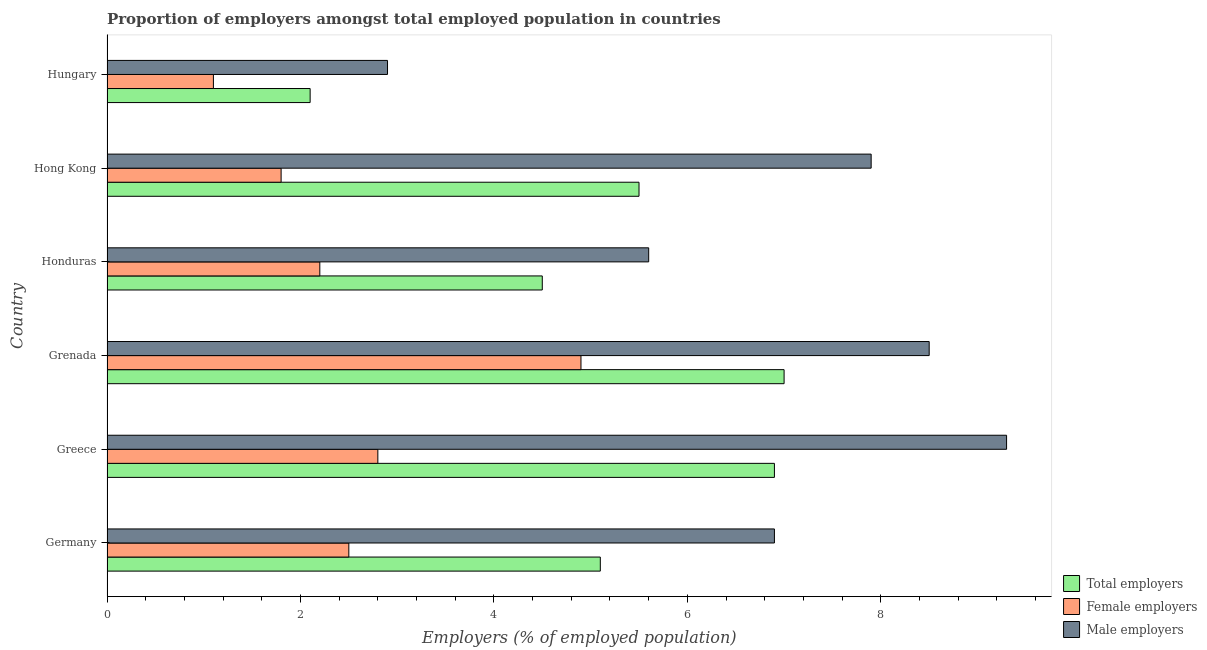How many different coloured bars are there?
Give a very brief answer. 3. How many groups of bars are there?
Provide a short and direct response. 6. Are the number of bars per tick equal to the number of legend labels?
Your answer should be compact. Yes. How many bars are there on the 1st tick from the top?
Keep it short and to the point. 3. What is the label of the 3rd group of bars from the top?
Your response must be concise. Honduras. What is the percentage of male employers in Hong Kong?
Provide a succinct answer. 7.9. Across all countries, what is the maximum percentage of total employers?
Provide a succinct answer. 7. Across all countries, what is the minimum percentage of female employers?
Provide a succinct answer. 1.1. In which country was the percentage of male employers minimum?
Make the answer very short. Hungary. What is the total percentage of male employers in the graph?
Give a very brief answer. 41.1. What is the difference between the percentage of total employers in Grenada and that in Hungary?
Ensure brevity in your answer.  4.9. What is the difference between the percentage of male employers in Hungary and the percentage of total employers in Greece?
Your response must be concise. -4. What is the average percentage of total employers per country?
Your answer should be compact. 5.18. What is the difference between the percentage of total employers and percentage of male employers in Greece?
Your response must be concise. -2.4. In how many countries, is the percentage of male employers greater than 3.6 %?
Provide a short and direct response. 5. What is the ratio of the percentage of total employers in Germany to that in Hungary?
Ensure brevity in your answer.  2.43. Is the percentage of female employers in Greece less than that in Honduras?
Make the answer very short. No. Is the difference between the percentage of male employers in Honduras and Hong Kong greater than the difference between the percentage of total employers in Honduras and Hong Kong?
Offer a terse response. No. What does the 3rd bar from the top in Germany represents?
Your answer should be compact. Total employers. What does the 1st bar from the bottom in Hong Kong represents?
Give a very brief answer. Total employers. How many bars are there?
Ensure brevity in your answer.  18. How many countries are there in the graph?
Offer a terse response. 6. Does the graph contain any zero values?
Keep it short and to the point. No. Where does the legend appear in the graph?
Provide a short and direct response. Bottom right. What is the title of the graph?
Make the answer very short. Proportion of employers amongst total employed population in countries. Does "Social Protection" appear as one of the legend labels in the graph?
Provide a short and direct response. No. What is the label or title of the X-axis?
Provide a short and direct response. Employers (% of employed population). What is the label or title of the Y-axis?
Provide a succinct answer. Country. What is the Employers (% of employed population) of Total employers in Germany?
Your answer should be very brief. 5.1. What is the Employers (% of employed population) of Female employers in Germany?
Offer a terse response. 2.5. What is the Employers (% of employed population) of Male employers in Germany?
Provide a succinct answer. 6.9. What is the Employers (% of employed population) of Total employers in Greece?
Ensure brevity in your answer.  6.9. What is the Employers (% of employed population) in Female employers in Greece?
Your response must be concise. 2.8. What is the Employers (% of employed population) in Male employers in Greece?
Your answer should be very brief. 9.3. What is the Employers (% of employed population) in Female employers in Grenada?
Provide a succinct answer. 4.9. What is the Employers (% of employed population) of Total employers in Honduras?
Your response must be concise. 4.5. What is the Employers (% of employed population) in Female employers in Honduras?
Keep it short and to the point. 2.2. What is the Employers (% of employed population) in Male employers in Honduras?
Make the answer very short. 5.6. What is the Employers (% of employed population) of Total employers in Hong Kong?
Your answer should be compact. 5.5. What is the Employers (% of employed population) in Female employers in Hong Kong?
Your answer should be very brief. 1.8. What is the Employers (% of employed population) in Male employers in Hong Kong?
Provide a succinct answer. 7.9. What is the Employers (% of employed population) in Total employers in Hungary?
Offer a very short reply. 2.1. What is the Employers (% of employed population) in Female employers in Hungary?
Offer a very short reply. 1.1. What is the Employers (% of employed population) of Male employers in Hungary?
Ensure brevity in your answer.  2.9. Across all countries, what is the maximum Employers (% of employed population) in Total employers?
Your answer should be compact. 7. Across all countries, what is the maximum Employers (% of employed population) of Female employers?
Your response must be concise. 4.9. Across all countries, what is the maximum Employers (% of employed population) in Male employers?
Your answer should be compact. 9.3. Across all countries, what is the minimum Employers (% of employed population) in Total employers?
Your response must be concise. 2.1. Across all countries, what is the minimum Employers (% of employed population) of Female employers?
Your answer should be very brief. 1.1. Across all countries, what is the minimum Employers (% of employed population) of Male employers?
Your response must be concise. 2.9. What is the total Employers (% of employed population) in Total employers in the graph?
Offer a very short reply. 31.1. What is the total Employers (% of employed population) in Female employers in the graph?
Make the answer very short. 15.3. What is the total Employers (% of employed population) in Male employers in the graph?
Your answer should be very brief. 41.1. What is the difference between the Employers (% of employed population) of Female employers in Germany and that in Greece?
Give a very brief answer. -0.3. What is the difference between the Employers (% of employed population) of Female employers in Germany and that in Grenada?
Offer a very short reply. -2.4. What is the difference between the Employers (% of employed population) of Male employers in Germany and that in Grenada?
Ensure brevity in your answer.  -1.6. What is the difference between the Employers (% of employed population) of Male employers in Germany and that in Honduras?
Provide a succinct answer. 1.3. What is the difference between the Employers (% of employed population) in Total employers in Germany and that in Hong Kong?
Provide a short and direct response. -0.4. What is the difference between the Employers (% of employed population) in Female employers in Germany and that in Hong Kong?
Ensure brevity in your answer.  0.7. What is the difference between the Employers (% of employed population) of Male employers in Greece and that in Grenada?
Give a very brief answer. 0.8. What is the difference between the Employers (% of employed population) in Female employers in Greece and that in Hong Kong?
Your answer should be very brief. 1. What is the difference between the Employers (% of employed population) in Total employers in Greece and that in Hungary?
Provide a short and direct response. 4.8. What is the difference between the Employers (% of employed population) in Total employers in Grenada and that in Honduras?
Your response must be concise. 2.5. What is the difference between the Employers (% of employed population) in Male employers in Grenada and that in Hong Kong?
Keep it short and to the point. 0.6. What is the difference between the Employers (% of employed population) in Total employers in Grenada and that in Hungary?
Offer a very short reply. 4.9. What is the difference between the Employers (% of employed population) in Total employers in Honduras and that in Hong Kong?
Offer a very short reply. -1. What is the difference between the Employers (% of employed population) of Female employers in Honduras and that in Hong Kong?
Keep it short and to the point. 0.4. What is the difference between the Employers (% of employed population) of Female employers in Honduras and that in Hungary?
Your response must be concise. 1.1. What is the difference between the Employers (% of employed population) in Total employers in Hong Kong and that in Hungary?
Make the answer very short. 3.4. What is the difference between the Employers (% of employed population) in Male employers in Hong Kong and that in Hungary?
Offer a very short reply. 5. What is the difference between the Employers (% of employed population) in Total employers in Germany and the Employers (% of employed population) in Female employers in Greece?
Provide a short and direct response. 2.3. What is the difference between the Employers (% of employed population) of Total employers in Germany and the Employers (% of employed population) of Female employers in Grenada?
Offer a very short reply. 0.2. What is the difference between the Employers (% of employed population) of Total employers in Germany and the Employers (% of employed population) of Male employers in Grenada?
Give a very brief answer. -3.4. What is the difference between the Employers (% of employed population) of Female employers in Germany and the Employers (% of employed population) of Male employers in Grenada?
Give a very brief answer. -6. What is the difference between the Employers (% of employed population) in Total employers in Germany and the Employers (% of employed population) in Female employers in Hong Kong?
Your answer should be compact. 3.3. What is the difference between the Employers (% of employed population) in Total employers in Germany and the Employers (% of employed population) in Female employers in Hungary?
Offer a very short reply. 4. What is the difference between the Employers (% of employed population) in Female employers in Germany and the Employers (% of employed population) in Male employers in Hungary?
Your answer should be compact. -0.4. What is the difference between the Employers (% of employed population) of Total employers in Greece and the Employers (% of employed population) of Female employers in Grenada?
Offer a very short reply. 2. What is the difference between the Employers (% of employed population) in Total employers in Greece and the Employers (% of employed population) in Male employers in Grenada?
Offer a very short reply. -1.6. What is the difference between the Employers (% of employed population) in Total employers in Greece and the Employers (% of employed population) in Female employers in Honduras?
Ensure brevity in your answer.  4.7. What is the difference between the Employers (% of employed population) of Total employers in Greece and the Employers (% of employed population) of Male employers in Hong Kong?
Make the answer very short. -1. What is the difference between the Employers (% of employed population) of Female employers in Greece and the Employers (% of employed population) of Male employers in Hong Kong?
Provide a short and direct response. -5.1. What is the difference between the Employers (% of employed population) in Total employers in Greece and the Employers (% of employed population) in Male employers in Hungary?
Keep it short and to the point. 4. What is the difference between the Employers (% of employed population) of Female employers in Grenada and the Employers (% of employed population) of Male employers in Honduras?
Offer a very short reply. -0.7. What is the difference between the Employers (% of employed population) of Total employers in Grenada and the Employers (% of employed population) of Female employers in Hong Kong?
Offer a very short reply. 5.2. What is the difference between the Employers (% of employed population) in Female employers in Grenada and the Employers (% of employed population) in Male employers in Hong Kong?
Provide a short and direct response. -3. What is the difference between the Employers (% of employed population) of Total employers in Grenada and the Employers (% of employed population) of Male employers in Hungary?
Ensure brevity in your answer.  4.1. What is the difference between the Employers (% of employed population) in Female employers in Grenada and the Employers (% of employed population) in Male employers in Hungary?
Offer a very short reply. 2. What is the difference between the Employers (% of employed population) in Total employers in Honduras and the Employers (% of employed population) in Female employers in Hong Kong?
Your answer should be compact. 2.7. What is the difference between the Employers (% of employed population) in Total employers in Honduras and the Employers (% of employed population) in Male employers in Hong Kong?
Your answer should be very brief. -3.4. What is the difference between the Employers (% of employed population) in Female employers in Honduras and the Employers (% of employed population) in Male employers in Hong Kong?
Provide a succinct answer. -5.7. What is the difference between the Employers (% of employed population) in Total employers in Honduras and the Employers (% of employed population) in Female employers in Hungary?
Provide a short and direct response. 3.4. What is the difference between the Employers (% of employed population) of Female employers in Honduras and the Employers (% of employed population) of Male employers in Hungary?
Provide a short and direct response. -0.7. What is the difference between the Employers (% of employed population) in Total employers in Hong Kong and the Employers (% of employed population) in Female employers in Hungary?
Offer a very short reply. 4.4. What is the average Employers (% of employed population) in Total employers per country?
Keep it short and to the point. 5.18. What is the average Employers (% of employed population) of Female employers per country?
Provide a short and direct response. 2.55. What is the average Employers (% of employed population) in Male employers per country?
Give a very brief answer. 6.85. What is the difference between the Employers (% of employed population) in Total employers and Employers (% of employed population) in Female employers in Germany?
Offer a terse response. 2.6. What is the difference between the Employers (% of employed population) of Total employers and Employers (% of employed population) of Male employers in Germany?
Offer a terse response. -1.8. What is the difference between the Employers (% of employed population) in Female employers and Employers (% of employed population) in Male employers in Germany?
Provide a succinct answer. -4.4. What is the difference between the Employers (% of employed population) of Female employers and Employers (% of employed population) of Male employers in Greece?
Keep it short and to the point. -6.5. What is the difference between the Employers (% of employed population) in Total employers and Employers (% of employed population) in Female employers in Grenada?
Your response must be concise. 2.1. What is the difference between the Employers (% of employed population) of Total employers and Employers (% of employed population) of Male employers in Honduras?
Your response must be concise. -1.1. What is the difference between the Employers (% of employed population) of Total employers and Employers (% of employed population) of Female employers in Hong Kong?
Your answer should be very brief. 3.7. What is the difference between the Employers (% of employed population) in Female employers and Employers (% of employed population) in Male employers in Hong Kong?
Offer a very short reply. -6.1. What is the difference between the Employers (% of employed population) in Total employers and Employers (% of employed population) in Female employers in Hungary?
Give a very brief answer. 1. What is the difference between the Employers (% of employed population) in Total employers and Employers (% of employed population) in Male employers in Hungary?
Give a very brief answer. -0.8. What is the ratio of the Employers (% of employed population) in Total employers in Germany to that in Greece?
Give a very brief answer. 0.74. What is the ratio of the Employers (% of employed population) of Female employers in Germany to that in Greece?
Make the answer very short. 0.89. What is the ratio of the Employers (% of employed population) of Male employers in Germany to that in Greece?
Provide a succinct answer. 0.74. What is the ratio of the Employers (% of employed population) in Total employers in Germany to that in Grenada?
Your answer should be compact. 0.73. What is the ratio of the Employers (% of employed population) of Female employers in Germany to that in Grenada?
Provide a succinct answer. 0.51. What is the ratio of the Employers (% of employed population) in Male employers in Germany to that in Grenada?
Give a very brief answer. 0.81. What is the ratio of the Employers (% of employed population) of Total employers in Germany to that in Honduras?
Give a very brief answer. 1.13. What is the ratio of the Employers (% of employed population) of Female employers in Germany to that in Honduras?
Make the answer very short. 1.14. What is the ratio of the Employers (% of employed population) of Male employers in Germany to that in Honduras?
Ensure brevity in your answer.  1.23. What is the ratio of the Employers (% of employed population) in Total employers in Germany to that in Hong Kong?
Your response must be concise. 0.93. What is the ratio of the Employers (% of employed population) in Female employers in Germany to that in Hong Kong?
Provide a short and direct response. 1.39. What is the ratio of the Employers (% of employed population) in Male employers in Germany to that in Hong Kong?
Offer a terse response. 0.87. What is the ratio of the Employers (% of employed population) in Total employers in Germany to that in Hungary?
Your response must be concise. 2.43. What is the ratio of the Employers (% of employed population) of Female employers in Germany to that in Hungary?
Your answer should be compact. 2.27. What is the ratio of the Employers (% of employed population) of Male employers in Germany to that in Hungary?
Your answer should be compact. 2.38. What is the ratio of the Employers (% of employed population) in Total employers in Greece to that in Grenada?
Your answer should be very brief. 0.99. What is the ratio of the Employers (% of employed population) in Male employers in Greece to that in Grenada?
Offer a terse response. 1.09. What is the ratio of the Employers (% of employed population) of Total employers in Greece to that in Honduras?
Your response must be concise. 1.53. What is the ratio of the Employers (% of employed population) in Female employers in Greece to that in Honduras?
Keep it short and to the point. 1.27. What is the ratio of the Employers (% of employed population) of Male employers in Greece to that in Honduras?
Give a very brief answer. 1.66. What is the ratio of the Employers (% of employed population) in Total employers in Greece to that in Hong Kong?
Offer a very short reply. 1.25. What is the ratio of the Employers (% of employed population) of Female employers in Greece to that in Hong Kong?
Keep it short and to the point. 1.56. What is the ratio of the Employers (% of employed population) in Male employers in Greece to that in Hong Kong?
Ensure brevity in your answer.  1.18. What is the ratio of the Employers (% of employed population) in Total employers in Greece to that in Hungary?
Make the answer very short. 3.29. What is the ratio of the Employers (% of employed population) in Female employers in Greece to that in Hungary?
Offer a very short reply. 2.55. What is the ratio of the Employers (% of employed population) of Male employers in Greece to that in Hungary?
Offer a terse response. 3.21. What is the ratio of the Employers (% of employed population) of Total employers in Grenada to that in Honduras?
Your answer should be very brief. 1.56. What is the ratio of the Employers (% of employed population) in Female employers in Grenada to that in Honduras?
Provide a short and direct response. 2.23. What is the ratio of the Employers (% of employed population) in Male employers in Grenada to that in Honduras?
Keep it short and to the point. 1.52. What is the ratio of the Employers (% of employed population) of Total employers in Grenada to that in Hong Kong?
Provide a succinct answer. 1.27. What is the ratio of the Employers (% of employed population) in Female employers in Grenada to that in Hong Kong?
Provide a short and direct response. 2.72. What is the ratio of the Employers (% of employed population) in Male employers in Grenada to that in Hong Kong?
Make the answer very short. 1.08. What is the ratio of the Employers (% of employed population) of Female employers in Grenada to that in Hungary?
Offer a terse response. 4.45. What is the ratio of the Employers (% of employed population) in Male employers in Grenada to that in Hungary?
Ensure brevity in your answer.  2.93. What is the ratio of the Employers (% of employed population) of Total employers in Honduras to that in Hong Kong?
Provide a short and direct response. 0.82. What is the ratio of the Employers (% of employed population) in Female employers in Honduras to that in Hong Kong?
Keep it short and to the point. 1.22. What is the ratio of the Employers (% of employed population) in Male employers in Honduras to that in Hong Kong?
Offer a very short reply. 0.71. What is the ratio of the Employers (% of employed population) of Total employers in Honduras to that in Hungary?
Provide a short and direct response. 2.14. What is the ratio of the Employers (% of employed population) in Male employers in Honduras to that in Hungary?
Ensure brevity in your answer.  1.93. What is the ratio of the Employers (% of employed population) of Total employers in Hong Kong to that in Hungary?
Provide a short and direct response. 2.62. What is the ratio of the Employers (% of employed population) in Female employers in Hong Kong to that in Hungary?
Offer a very short reply. 1.64. What is the ratio of the Employers (% of employed population) in Male employers in Hong Kong to that in Hungary?
Your response must be concise. 2.72. 